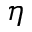<formula> <loc_0><loc_0><loc_500><loc_500>\eta</formula> 